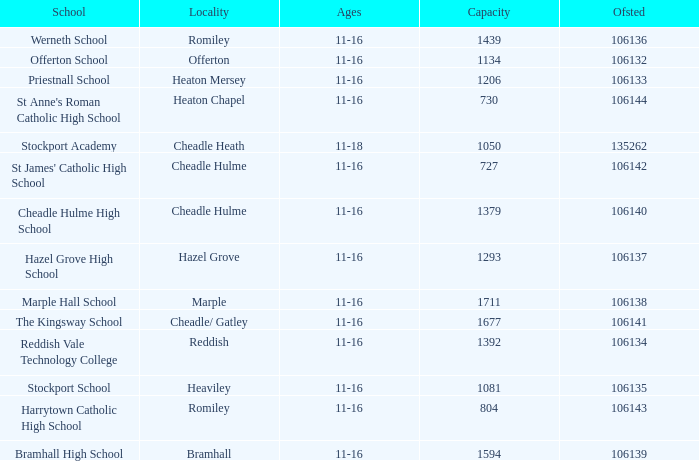Which Ofsted has a Capacity of 1677? 106141.0. 